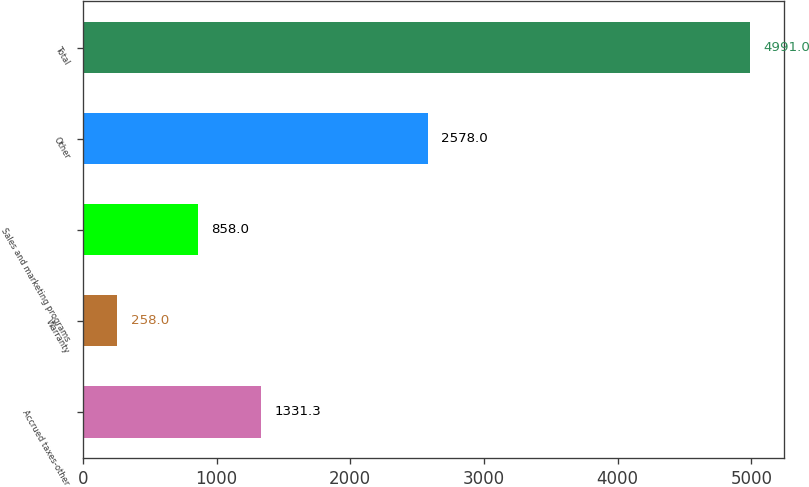Convert chart to OTSL. <chart><loc_0><loc_0><loc_500><loc_500><bar_chart><fcel>Accrued taxes-other<fcel>Warranty<fcel>Sales and marketing programs<fcel>Other<fcel>Total<nl><fcel>1331.3<fcel>258<fcel>858<fcel>2578<fcel>4991<nl></chart> 